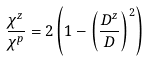Convert formula to latex. <formula><loc_0><loc_0><loc_500><loc_500>\frac { \chi ^ { z } } { \chi ^ { p } } = 2 \left ( 1 - \left ( \frac { D ^ { z } } { D } \right ) ^ { 2 } \right )</formula> 